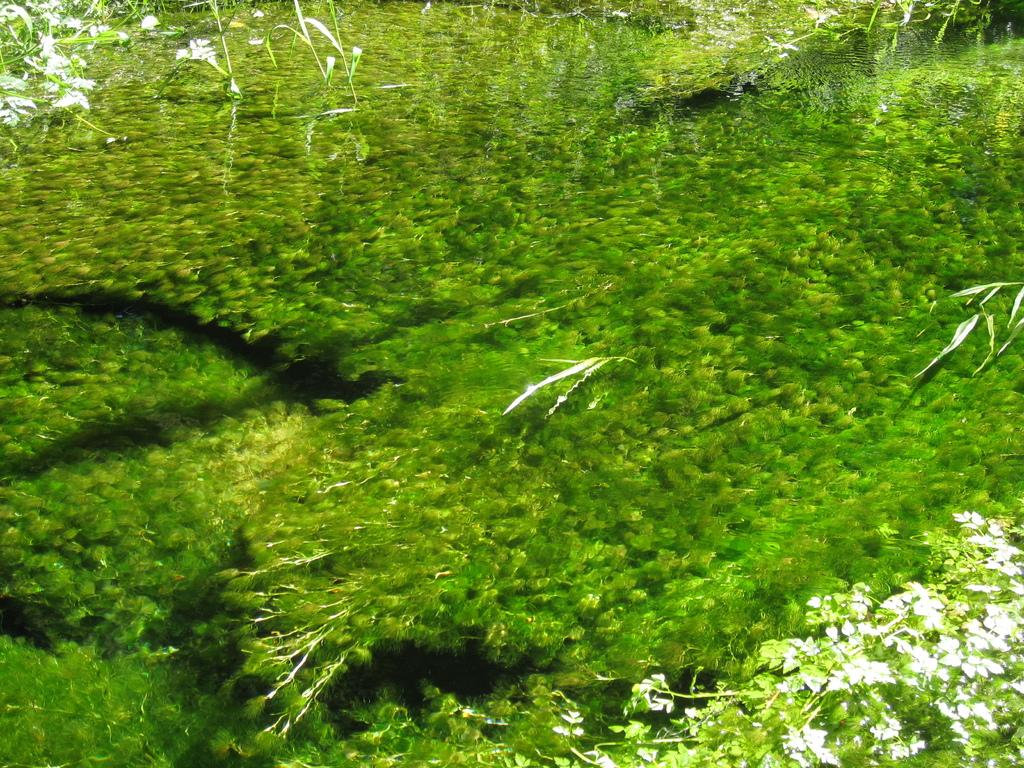What object can be seen in the image that is commonly used for hydration? There is a water bottle in the image. What is unique about the water in the image? There is greenery, possibly plants, in the water. What can be seen on the right side of the image? There are plants above the water on the right side of the image. What can be seen on the left side of the image? There are plants above the water on the left side of the image. How many fans are visible in the image? There are no fans present in the image. What type of snakes can be seen swimming in the water? There are no snakes present in the image; it features plants in the water. 